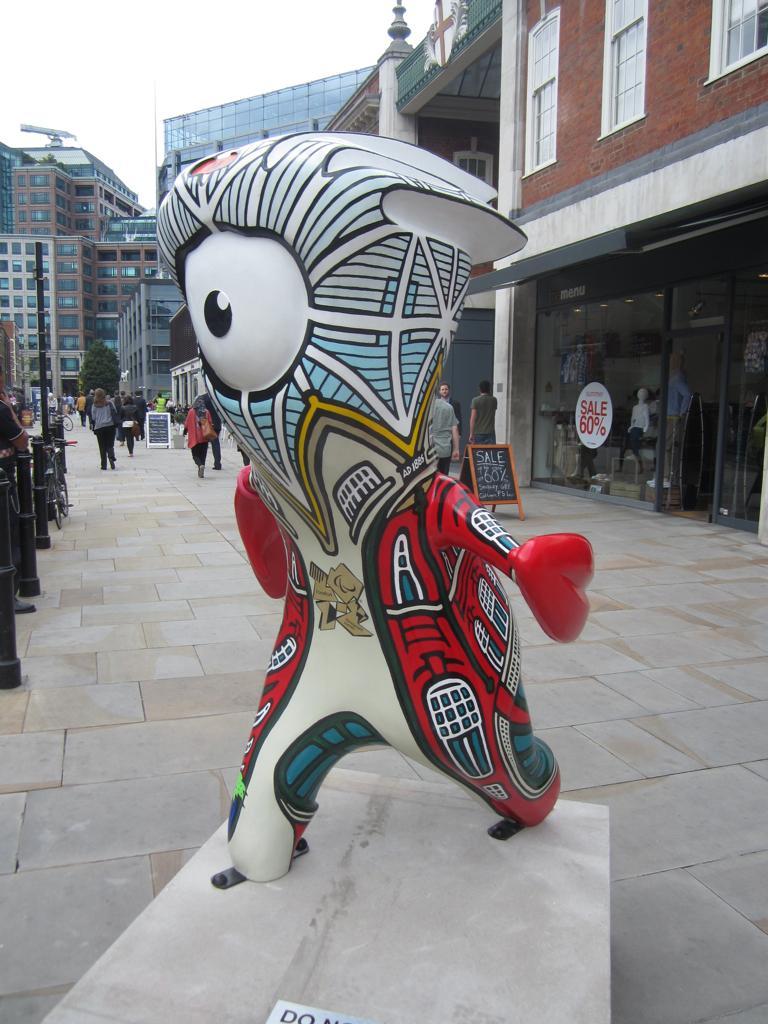Describe this image in one or two sentences. In the image we can inflatable toy statue and there are people walking, they are wearing clothes. We can even see there are buildings and these are the windows of the building. Here we can see the footpath, poles, board and the sky. 